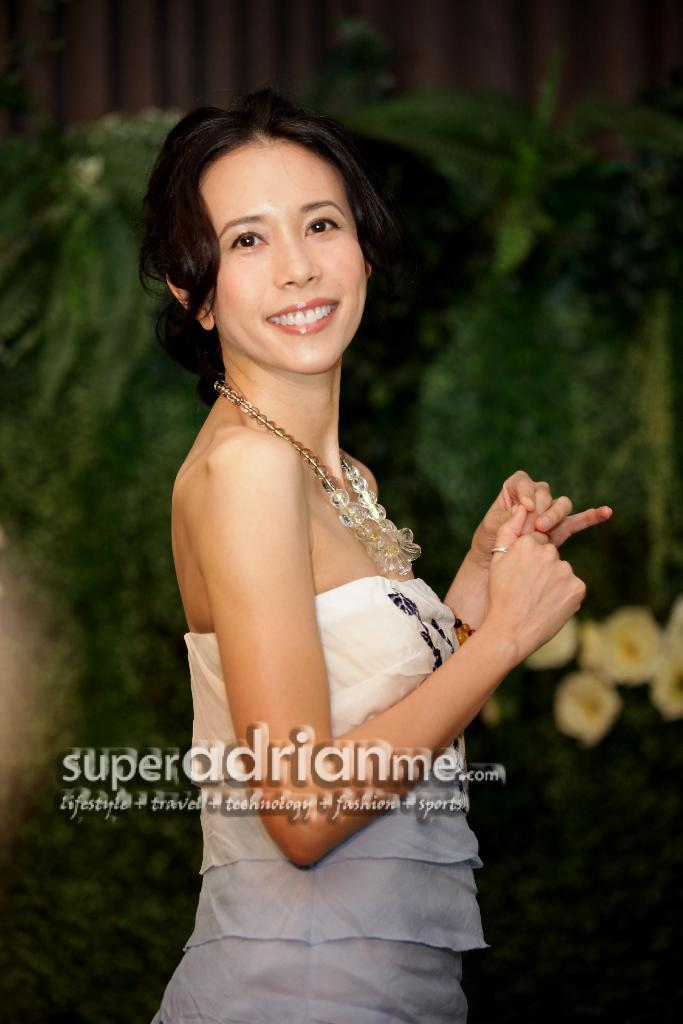What is the main subject in the foreground of the picture? There is a woman in the foreground of the picture. What is the woman wearing? The woman is wearing a white dress. What is the woman's facial expression? The woman is smiling. What can be seen in the background of the picture? There are flowers near plants and a railing in the background of the picture. What type of oatmeal is being served in the background of the picture? There is no oatmeal present in the image; it features a woman in the foreground and flowers, plants, and a railing in the background. How many kittens can be seen playing with the railing in the picture? There are no kittens present in the image. 